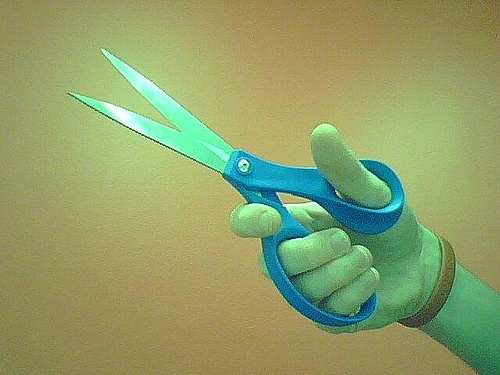Describe the objects in this image and their specific colors. I can see people in olive, green, lightgreen, and darkgreen tones and scissors in olive, teal, and aquamarine tones in this image. 